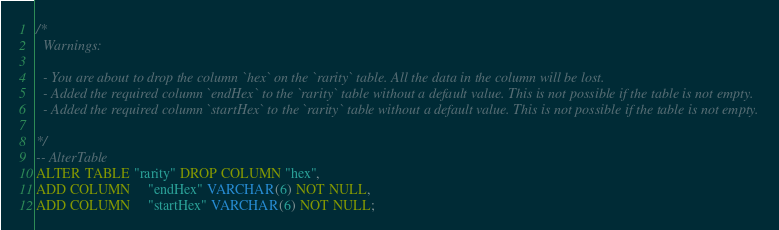Convert code to text. <code><loc_0><loc_0><loc_500><loc_500><_SQL_>/*
  Warnings:

  - You are about to drop the column `hex` on the `rarity` table. All the data in the column will be lost.
  - Added the required column `endHex` to the `rarity` table without a default value. This is not possible if the table is not empty.
  - Added the required column `startHex` to the `rarity` table without a default value. This is not possible if the table is not empty.

*/
-- AlterTable
ALTER TABLE "rarity" DROP COLUMN "hex",
ADD COLUMN     "endHex" VARCHAR(6) NOT NULL,
ADD COLUMN     "startHex" VARCHAR(6) NOT NULL;
</code> 